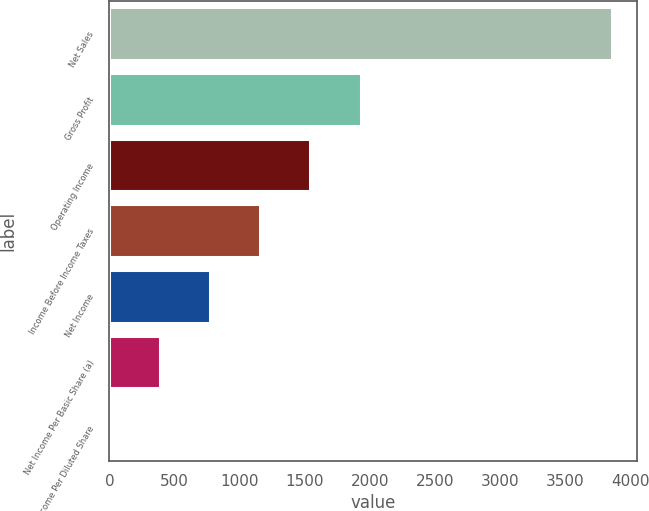Convert chart. <chart><loc_0><loc_0><loc_500><loc_500><bar_chart><fcel>Net Sales<fcel>Gross Profit<fcel>Operating Income<fcel>Income Before Income Taxes<fcel>Net Income<fcel>Net Income Per Basic Share (a)<fcel>Net Income Per Diluted Share<nl><fcel>3856<fcel>1928.69<fcel>1543.23<fcel>1157.77<fcel>772.31<fcel>386.85<fcel>1.39<nl></chart> 